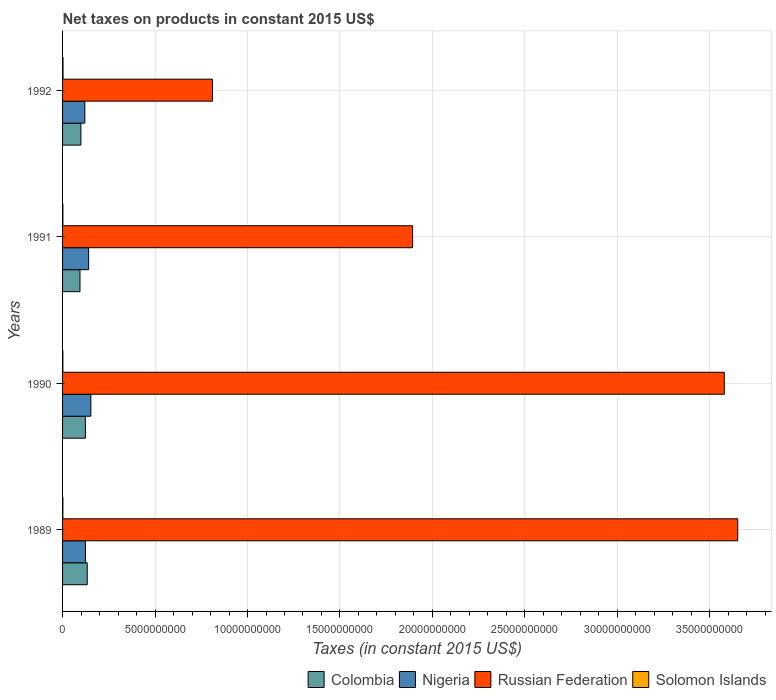How many different coloured bars are there?
Provide a short and direct response. 4. Are the number of bars per tick equal to the number of legend labels?
Keep it short and to the point. Yes. Are the number of bars on each tick of the Y-axis equal?
Offer a very short reply. Yes. How many bars are there on the 2nd tick from the bottom?
Your answer should be compact. 4. What is the label of the 1st group of bars from the top?
Ensure brevity in your answer.  1992. What is the net taxes on products in Colombia in 1990?
Your answer should be very brief. 1.23e+09. Across all years, what is the maximum net taxes on products in Russian Federation?
Keep it short and to the point. 3.65e+1. Across all years, what is the minimum net taxes on products in Russian Federation?
Keep it short and to the point. 8.10e+09. In which year was the net taxes on products in Nigeria maximum?
Provide a short and direct response. 1990. What is the total net taxes on products in Russian Federation in the graph?
Provide a succinct answer. 9.93e+1. What is the difference between the net taxes on products in Russian Federation in 1990 and that in 1992?
Your answer should be compact. 2.77e+1. What is the difference between the net taxes on products in Solomon Islands in 1991 and the net taxes on products in Russian Federation in 1989?
Your answer should be compact. -3.65e+1. What is the average net taxes on products in Nigeria per year?
Your answer should be compact. 1.34e+09. In the year 1991, what is the difference between the net taxes on products in Russian Federation and net taxes on products in Colombia?
Your answer should be compact. 1.80e+1. What is the ratio of the net taxes on products in Solomon Islands in 1990 to that in 1992?
Your answer should be very brief. 0.7. Is the net taxes on products in Solomon Islands in 1989 less than that in 1991?
Provide a short and direct response. Yes. What is the difference between the highest and the second highest net taxes on products in Nigeria?
Keep it short and to the point. 1.20e+08. What is the difference between the highest and the lowest net taxes on products in Nigeria?
Keep it short and to the point. 3.25e+08. What does the 2nd bar from the bottom in 1990 represents?
Give a very brief answer. Nigeria. Are all the bars in the graph horizontal?
Your answer should be compact. Yes. Does the graph contain any zero values?
Make the answer very short. No. How are the legend labels stacked?
Give a very brief answer. Horizontal. What is the title of the graph?
Offer a terse response. Net taxes on products in constant 2015 US$. Does "Greenland" appear as one of the legend labels in the graph?
Your response must be concise. No. What is the label or title of the X-axis?
Ensure brevity in your answer.  Taxes (in constant 2015 US$). What is the Taxes (in constant 2015 US$) of Colombia in 1989?
Your response must be concise. 1.33e+09. What is the Taxes (in constant 2015 US$) of Nigeria in 1989?
Ensure brevity in your answer.  1.24e+09. What is the Taxes (in constant 2015 US$) of Russian Federation in 1989?
Your answer should be compact. 3.65e+1. What is the Taxes (in constant 2015 US$) of Solomon Islands in 1989?
Give a very brief answer. 1.64e+07. What is the Taxes (in constant 2015 US$) in Colombia in 1990?
Your answer should be very brief. 1.23e+09. What is the Taxes (in constant 2015 US$) in Nigeria in 1990?
Your answer should be very brief. 1.53e+09. What is the Taxes (in constant 2015 US$) of Russian Federation in 1990?
Your response must be concise. 3.58e+1. What is the Taxes (in constant 2015 US$) in Solomon Islands in 1990?
Provide a short and direct response. 1.66e+07. What is the Taxes (in constant 2015 US$) in Colombia in 1991?
Provide a succinct answer. 9.42e+08. What is the Taxes (in constant 2015 US$) of Nigeria in 1991?
Your answer should be very brief. 1.41e+09. What is the Taxes (in constant 2015 US$) of Russian Federation in 1991?
Keep it short and to the point. 1.89e+1. What is the Taxes (in constant 2015 US$) in Solomon Islands in 1991?
Keep it short and to the point. 1.75e+07. What is the Taxes (in constant 2015 US$) in Colombia in 1992?
Your answer should be compact. 9.90e+08. What is the Taxes (in constant 2015 US$) in Nigeria in 1992?
Provide a succinct answer. 1.20e+09. What is the Taxes (in constant 2015 US$) in Russian Federation in 1992?
Your answer should be compact. 8.10e+09. What is the Taxes (in constant 2015 US$) in Solomon Islands in 1992?
Your answer should be compact. 2.39e+07. Across all years, what is the maximum Taxes (in constant 2015 US$) in Colombia?
Provide a short and direct response. 1.33e+09. Across all years, what is the maximum Taxes (in constant 2015 US$) of Nigeria?
Offer a very short reply. 1.53e+09. Across all years, what is the maximum Taxes (in constant 2015 US$) in Russian Federation?
Give a very brief answer. 3.65e+1. Across all years, what is the maximum Taxes (in constant 2015 US$) of Solomon Islands?
Provide a succinct answer. 2.39e+07. Across all years, what is the minimum Taxes (in constant 2015 US$) of Colombia?
Your answer should be compact. 9.42e+08. Across all years, what is the minimum Taxes (in constant 2015 US$) in Nigeria?
Your answer should be compact. 1.20e+09. Across all years, what is the minimum Taxes (in constant 2015 US$) of Russian Federation?
Ensure brevity in your answer.  8.10e+09. Across all years, what is the minimum Taxes (in constant 2015 US$) of Solomon Islands?
Offer a very short reply. 1.64e+07. What is the total Taxes (in constant 2015 US$) of Colombia in the graph?
Offer a very short reply. 4.50e+09. What is the total Taxes (in constant 2015 US$) in Nigeria in the graph?
Offer a very short reply. 5.38e+09. What is the total Taxes (in constant 2015 US$) in Russian Federation in the graph?
Provide a succinct answer. 9.93e+1. What is the total Taxes (in constant 2015 US$) in Solomon Islands in the graph?
Your answer should be compact. 7.44e+07. What is the difference between the Taxes (in constant 2015 US$) of Colombia in 1989 and that in 1990?
Give a very brief answer. 1.00e+08. What is the difference between the Taxes (in constant 2015 US$) of Nigeria in 1989 and that in 1990?
Keep it short and to the point. -2.93e+08. What is the difference between the Taxes (in constant 2015 US$) in Russian Federation in 1989 and that in 1990?
Your answer should be very brief. 7.26e+08. What is the difference between the Taxes (in constant 2015 US$) in Solomon Islands in 1989 and that in 1990?
Give a very brief answer. -2.52e+05. What is the difference between the Taxes (in constant 2015 US$) of Colombia in 1989 and that in 1991?
Ensure brevity in your answer.  3.92e+08. What is the difference between the Taxes (in constant 2015 US$) of Nigeria in 1989 and that in 1991?
Ensure brevity in your answer.  -1.73e+08. What is the difference between the Taxes (in constant 2015 US$) in Russian Federation in 1989 and that in 1991?
Give a very brief answer. 1.76e+1. What is the difference between the Taxes (in constant 2015 US$) of Solomon Islands in 1989 and that in 1991?
Offer a very short reply. -1.06e+06. What is the difference between the Taxes (in constant 2015 US$) of Colombia in 1989 and that in 1992?
Offer a terse response. 3.43e+08. What is the difference between the Taxes (in constant 2015 US$) of Nigeria in 1989 and that in 1992?
Your response must be concise. 3.17e+07. What is the difference between the Taxes (in constant 2015 US$) of Russian Federation in 1989 and that in 1992?
Your answer should be compact. 2.84e+1. What is the difference between the Taxes (in constant 2015 US$) of Solomon Islands in 1989 and that in 1992?
Your answer should be very brief. -7.51e+06. What is the difference between the Taxes (in constant 2015 US$) in Colombia in 1990 and that in 1991?
Your response must be concise. 2.91e+08. What is the difference between the Taxes (in constant 2015 US$) of Nigeria in 1990 and that in 1991?
Your answer should be compact. 1.20e+08. What is the difference between the Taxes (in constant 2015 US$) of Russian Federation in 1990 and that in 1991?
Your answer should be very brief. 1.69e+1. What is the difference between the Taxes (in constant 2015 US$) of Solomon Islands in 1990 and that in 1991?
Offer a very short reply. -8.12e+05. What is the difference between the Taxes (in constant 2015 US$) in Colombia in 1990 and that in 1992?
Your response must be concise. 2.43e+08. What is the difference between the Taxes (in constant 2015 US$) of Nigeria in 1990 and that in 1992?
Keep it short and to the point. 3.25e+08. What is the difference between the Taxes (in constant 2015 US$) in Russian Federation in 1990 and that in 1992?
Ensure brevity in your answer.  2.77e+1. What is the difference between the Taxes (in constant 2015 US$) in Solomon Islands in 1990 and that in 1992?
Keep it short and to the point. -7.26e+06. What is the difference between the Taxes (in constant 2015 US$) in Colombia in 1991 and that in 1992?
Your answer should be compact. -4.86e+07. What is the difference between the Taxes (in constant 2015 US$) in Nigeria in 1991 and that in 1992?
Ensure brevity in your answer.  2.05e+08. What is the difference between the Taxes (in constant 2015 US$) in Russian Federation in 1991 and that in 1992?
Keep it short and to the point. 1.08e+1. What is the difference between the Taxes (in constant 2015 US$) in Solomon Islands in 1991 and that in 1992?
Your response must be concise. -6.45e+06. What is the difference between the Taxes (in constant 2015 US$) of Colombia in 1989 and the Taxes (in constant 2015 US$) of Nigeria in 1990?
Make the answer very short. -1.96e+08. What is the difference between the Taxes (in constant 2015 US$) of Colombia in 1989 and the Taxes (in constant 2015 US$) of Russian Federation in 1990?
Your response must be concise. -3.44e+1. What is the difference between the Taxes (in constant 2015 US$) in Colombia in 1989 and the Taxes (in constant 2015 US$) in Solomon Islands in 1990?
Keep it short and to the point. 1.32e+09. What is the difference between the Taxes (in constant 2015 US$) of Nigeria in 1989 and the Taxes (in constant 2015 US$) of Russian Federation in 1990?
Offer a terse response. -3.45e+1. What is the difference between the Taxes (in constant 2015 US$) of Nigeria in 1989 and the Taxes (in constant 2015 US$) of Solomon Islands in 1990?
Provide a short and direct response. 1.22e+09. What is the difference between the Taxes (in constant 2015 US$) of Russian Federation in 1989 and the Taxes (in constant 2015 US$) of Solomon Islands in 1990?
Provide a short and direct response. 3.65e+1. What is the difference between the Taxes (in constant 2015 US$) in Colombia in 1989 and the Taxes (in constant 2015 US$) in Nigeria in 1991?
Provide a succinct answer. -7.58e+07. What is the difference between the Taxes (in constant 2015 US$) in Colombia in 1989 and the Taxes (in constant 2015 US$) in Russian Federation in 1991?
Provide a short and direct response. -1.76e+1. What is the difference between the Taxes (in constant 2015 US$) of Colombia in 1989 and the Taxes (in constant 2015 US$) of Solomon Islands in 1991?
Your answer should be very brief. 1.32e+09. What is the difference between the Taxes (in constant 2015 US$) in Nigeria in 1989 and the Taxes (in constant 2015 US$) in Russian Federation in 1991?
Provide a short and direct response. -1.77e+1. What is the difference between the Taxes (in constant 2015 US$) of Nigeria in 1989 and the Taxes (in constant 2015 US$) of Solomon Islands in 1991?
Offer a very short reply. 1.22e+09. What is the difference between the Taxes (in constant 2015 US$) in Russian Federation in 1989 and the Taxes (in constant 2015 US$) in Solomon Islands in 1991?
Provide a succinct answer. 3.65e+1. What is the difference between the Taxes (in constant 2015 US$) in Colombia in 1989 and the Taxes (in constant 2015 US$) in Nigeria in 1992?
Your answer should be compact. 1.29e+08. What is the difference between the Taxes (in constant 2015 US$) in Colombia in 1989 and the Taxes (in constant 2015 US$) in Russian Federation in 1992?
Offer a very short reply. -6.77e+09. What is the difference between the Taxes (in constant 2015 US$) of Colombia in 1989 and the Taxes (in constant 2015 US$) of Solomon Islands in 1992?
Give a very brief answer. 1.31e+09. What is the difference between the Taxes (in constant 2015 US$) in Nigeria in 1989 and the Taxes (in constant 2015 US$) in Russian Federation in 1992?
Keep it short and to the point. -6.87e+09. What is the difference between the Taxes (in constant 2015 US$) in Nigeria in 1989 and the Taxes (in constant 2015 US$) in Solomon Islands in 1992?
Provide a short and direct response. 1.21e+09. What is the difference between the Taxes (in constant 2015 US$) of Russian Federation in 1989 and the Taxes (in constant 2015 US$) of Solomon Islands in 1992?
Provide a succinct answer. 3.65e+1. What is the difference between the Taxes (in constant 2015 US$) of Colombia in 1990 and the Taxes (in constant 2015 US$) of Nigeria in 1991?
Your answer should be very brief. -1.76e+08. What is the difference between the Taxes (in constant 2015 US$) of Colombia in 1990 and the Taxes (in constant 2015 US$) of Russian Federation in 1991?
Offer a very short reply. -1.77e+1. What is the difference between the Taxes (in constant 2015 US$) in Colombia in 1990 and the Taxes (in constant 2015 US$) in Solomon Islands in 1991?
Offer a terse response. 1.22e+09. What is the difference between the Taxes (in constant 2015 US$) in Nigeria in 1990 and the Taxes (in constant 2015 US$) in Russian Federation in 1991?
Your response must be concise. -1.74e+1. What is the difference between the Taxes (in constant 2015 US$) of Nigeria in 1990 and the Taxes (in constant 2015 US$) of Solomon Islands in 1991?
Provide a short and direct response. 1.51e+09. What is the difference between the Taxes (in constant 2015 US$) in Russian Federation in 1990 and the Taxes (in constant 2015 US$) in Solomon Islands in 1991?
Offer a terse response. 3.58e+1. What is the difference between the Taxes (in constant 2015 US$) in Colombia in 1990 and the Taxes (in constant 2015 US$) in Nigeria in 1992?
Keep it short and to the point. 2.87e+07. What is the difference between the Taxes (in constant 2015 US$) in Colombia in 1990 and the Taxes (in constant 2015 US$) in Russian Federation in 1992?
Your answer should be very brief. -6.87e+09. What is the difference between the Taxes (in constant 2015 US$) of Colombia in 1990 and the Taxes (in constant 2015 US$) of Solomon Islands in 1992?
Offer a terse response. 1.21e+09. What is the difference between the Taxes (in constant 2015 US$) in Nigeria in 1990 and the Taxes (in constant 2015 US$) in Russian Federation in 1992?
Provide a short and direct response. -6.57e+09. What is the difference between the Taxes (in constant 2015 US$) of Nigeria in 1990 and the Taxes (in constant 2015 US$) of Solomon Islands in 1992?
Provide a short and direct response. 1.51e+09. What is the difference between the Taxes (in constant 2015 US$) of Russian Federation in 1990 and the Taxes (in constant 2015 US$) of Solomon Islands in 1992?
Provide a short and direct response. 3.58e+1. What is the difference between the Taxes (in constant 2015 US$) in Colombia in 1991 and the Taxes (in constant 2015 US$) in Nigeria in 1992?
Offer a very short reply. -2.63e+08. What is the difference between the Taxes (in constant 2015 US$) of Colombia in 1991 and the Taxes (in constant 2015 US$) of Russian Federation in 1992?
Your answer should be very brief. -7.16e+09. What is the difference between the Taxes (in constant 2015 US$) in Colombia in 1991 and the Taxes (in constant 2015 US$) in Solomon Islands in 1992?
Your answer should be very brief. 9.18e+08. What is the difference between the Taxes (in constant 2015 US$) of Nigeria in 1991 and the Taxes (in constant 2015 US$) of Russian Federation in 1992?
Provide a succinct answer. -6.69e+09. What is the difference between the Taxes (in constant 2015 US$) of Nigeria in 1991 and the Taxes (in constant 2015 US$) of Solomon Islands in 1992?
Make the answer very short. 1.39e+09. What is the difference between the Taxes (in constant 2015 US$) of Russian Federation in 1991 and the Taxes (in constant 2015 US$) of Solomon Islands in 1992?
Offer a very short reply. 1.89e+1. What is the average Taxes (in constant 2015 US$) of Colombia per year?
Keep it short and to the point. 1.12e+09. What is the average Taxes (in constant 2015 US$) of Nigeria per year?
Your answer should be very brief. 1.34e+09. What is the average Taxes (in constant 2015 US$) of Russian Federation per year?
Your answer should be very brief. 2.48e+1. What is the average Taxes (in constant 2015 US$) of Solomon Islands per year?
Your answer should be very brief. 1.86e+07. In the year 1989, what is the difference between the Taxes (in constant 2015 US$) in Colombia and Taxes (in constant 2015 US$) in Nigeria?
Make the answer very short. 9.75e+07. In the year 1989, what is the difference between the Taxes (in constant 2015 US$) of Colombia and Taxes (in constant 2015 US$) of Russian Federation?
Give a very brief answer. -3.52e+1. In the year 1989, what is the difference between the Taxes (in constant 2015 US$) in Colombia and Taxes (in constant 2015 US$) in Solomon Islands?
Provide a succinct answer. 1.32e+09. In the year 1989, what is the difference between the Taxes (in constant 2015 US$) of Nigeria and Taxes (in constant 2015 US$) of Russian Federation?
Provide a short and direct response. -3.53e+1. In the year 1989, what is the difference between the Taxes (in constant 2015 US$) in Nigeria and Taxes (in constant 2015 US$) in Solomon Islands?
Keep it short and to the point. 1.22e+09. In the year 1989, what is the difference between the Taxes (in constant 2015 US$) of Russian Federation and Taxes (in constant 2015 US$) of Solomon Islands?
Keep it short and to the point. 3.65e+1. In the year 1990, what is the difference between the Taxes (in constant 2015 US$) of Colombia and Taxes (in constant 2015 US$) of Nigeria?
Keep it short and to the point. -2.96e+08. In the year 1990, what is the difference between the Taxes (in constant 2015 US$) of Colombia and Taxes (in constant 2015 US$) of Russian Federation?
Ensure brevity in your answer.  -3.45e+1. In the year 1990, what is the difference between the Taxes (in constant 2015 US$) in Colombia and Taxes (in constant 2015 US$) in Solomon Islands?
Provide a short and direct response. 1.22e+09. In the year 1990, what is the difference between the Taxes (in constant 2015 US$) in Nigeria and Taxes (in constant 2015 US$) in Russian Federation?
Offer a very short reply. -3.43e+1. In the year 1990, what is the difference between the Taxes (in constant 2015 US$) of Nigeria and Taxes (in constant 2015 US$) of Solomon Islands?
Provide a short and direct response. 1.51e+09. In the year 1990, what is the difference between the Taxes (in constant 2015 US$) in Russian Federation and Taxes (in constant 2015 US$) in Solomon Islands?
Keep it short and to the point. 3.58e+1. In the year 1991, what is the difference between the Taxes (in constant 2015 US$) of Colombia and Taxes (in constant 2015 US$) of Nigeria?
Your answer should be compact. -4.68e+08. In the year 1991, what is the difference between the Taxes (in constant 2015 US$) in Colombia and Taxes (in constant 2015 US$) in Russian Federation?
Keep it short and to the point. -1.80e+1. In the year 1991, what is the difference between the Taxes (in constant 2015 US$) in Colombia and Taxes (in constant 2015 US$) in Solomon Islands?
Give a very brief answer. 9.24e+08. In the year 1991, what is the difference between the Taxes (in constant 2015 US$) of Nigeria and Taxes (in constant 2015 US$) of Russian Federation?
Your answer should be compact. -1.75e+1. In the year 1991, what is the difference between the Taxes (in constant 2015 US$) of Nigeria and Taxes (in constant 2015 US$) of Solomon Islands?
Ensure brevity in your answer.  1.39e+09. In the year 1991, what is the difference between the Taxes (in constant 2015 US$) of Russian Federation and Taxes (in constant 2015 US$) of Solomon Islands?
Provide a short and direct response. 1.89e+1. In the year 1992, what is the difference between the Taxes (in constant 2015 US$) in Colombia and Taxes (in constant 2015 US$) in Nigeria?
Offer a very short reply. -2.14e+08. In the year 1992, what is the difference between the Taxes (in constant 2015 US$) of Colombia and Taxes (in constant 2015 US$) of Russian Federation?
Provide a short and direct response. -7.11e+09. In the year 1992, what is the difference between the Taxes (in constant 2015 US$) in Colombia and Taxes (in constant 2015 US$) in Solomon Islands?
Your response must be concise. 9.66e+08. In the year 1992, what is the difference between the Taxes (in constant 2015 US$) in Nigeria and Taxes (in constant 2015 US$) in Russian Federation?
Make the answer very short. -6.90e+09. In the year 1992, what is the difference between the Taxes (in constant 2015 US$) in Nigeria and Taxes (in constant 2015 US$) in Solomon Islands?
Provide a succinct answer. 1.18e+09. In the year 1992, what is the difference between the Taxes (in constant 2015 US$) in Russian Federation and Taxes (in constant 2015 US$) in Solomon Islands?
Your answer should be very brief. 8.08e+09. What is the ratio of the Taxes (in constant 2015 US$) of Colombia in 1989 to that in 1990?
Your answer should be very brief. 1.08. What is the ratio of the Taxes (in constant 2015 US$) in Nigeria in 1989 to that in 1990?
Your response must be concise. 0.81. What is the ratio of the Taxes (in constant 2015 US$) of Russian Federation in 1989 to that in 1990?
Give a very brief answer. 1.02. What is the ratio of the Taxes (in constant 2015 US$) of Solomon Islands in 1989 to that in 1990?
Your response must be concise. 0.98. What is the ratio of the Taxes (in constant 2015 US$) in Colombia in 1989 to that in 1991?
Give a very brief answer. 1.42. What is the ratio of the Taxes (in constant 2015 US$) of Nigeria in 1989 to that in 1991?
Give a very brief answer. 0.88. What is the ratio of the Taxes (in constant 2015 US$) in Russian Federation in 1989 to that in 1991?
Give a very brief answer. 1.93. What is the ratio of the Taxes (in constant 2015 US$) in Solomon Islands in 1989 to that in 1991?
Provide a short and direct response. 0.94. What is the ratio of the Taxes (in constant 2015 US$) of Colombia in 1989 to that in 1992?
Your answer should be compact. 1.35. What is the ratio of the Taxes (in constant 2015 US$) in Nigeria in 1989 to that in 1992?
Your answer should be compact. 1.03. What is the ratio of the Taxes (in constant 2015 US$) in Russian Federation in 1989 to that in 1992?
Your answer should be very brief. 4.5. What is the ratio of the Taxes (in constant 2015 US$) in Solomon Islands in 1989 to that in 1992?
Keep it short and to the point. 0.69. What is the ratio of the Taxes (in constant 2015 US$) of Colombia in 1990 to that in 1991?
Your answer should be compact. 1.31. What is the ratio of the Taxes (in constant 2015 US$) of Nigeria in 1990 to that in 1991?
Keep it short and to the point. 1.09. What is the ratio of the Taxes (in constant 2015 US$) of Russian Federation in 1990 to that in 1991?
Provide a short and direct response. 1.89. What is the ratio of the Taxes (in constant 2015 US$) in Solomon Islands in 1990 to that in 1991?
Ensure brevity in your answer.  0.95. What is the ratio of the Taxes (in constant 2015 US$) in Colombia in 1990 to that in 1992?
Make the answer very short. 1.25. What is the ratio of the Taxes (in constant 2015 US$) in Nigeria in 1990 to that in 1992?
Keep it short and to the point. 1.27. What is the ratio of the Taxes (in constant 2015 US$) of Russian Federation in 1990 to that in 1992?
Your answer should be very brief. 4.42. What is the ratio of the Taxes (in constant 2015 US$) in Solomon Islands in 1990 to that in 1992?
Keep it short and to the point. 0.7. What is the ratio of the Taxes (in constant 2015 US$) in Colombia in 1991 to that in 1992?
Your response must be concise. 0.95. What is the ratio of the Taxes (in constant 2015 US$) in Nigeria in 1991 to that in 1992?
Your response must be concise. 1.17. What is the ratio of the Taxes (in constant 2015 US$) in Russian Federation in 1991 to that in 1992?
Your response must be concise. 2.34. What is the ratio of the Taxes (in constant 2015 US$) of Solomon Islands in 1991 to that in 1992?
Provide a short and direct response. 0.73. What is the difference between the highest and the second highest Taxes (in constant 2015 US$) of Colombia?
Your answer should be very brief. 1.00e+08. What is the difference between the highest and the second highest Taxes (in constant 2015 US$) in Nigeria?
Ensure brevity in your answer.  1.20e+08. What is the difference between the highest and the second highest Taxes (in constant 2015 US$) in Russian Federation?
Give a very brief answer. 7.26e+08. What is the difference between the highest and the second highest Taxes (in constant 2015 US$) in Solomon Islands?
Make the answer very short. 6.45e+06. What is the difference between the highest and the lowest Taxes (in constant 2015 US$) of Colombia?
Provide a short and direct response. 3.92e+08. What is the difference between the highest and the lowest Taxes (in constant 2015 US$) in Nigeria?
Give a very brief answer. 3.25e+08. What is the difference between the highest and the lowest Taxes (in constant 2015 US$) of Russian Federation?
Your answer should be very brief. 2.84e+1. What is the difference between the highest and the lowest Taxes (in constant 2015 US$) of Solomon Islands?
Your answer should be very brief. 7.51e+06. 